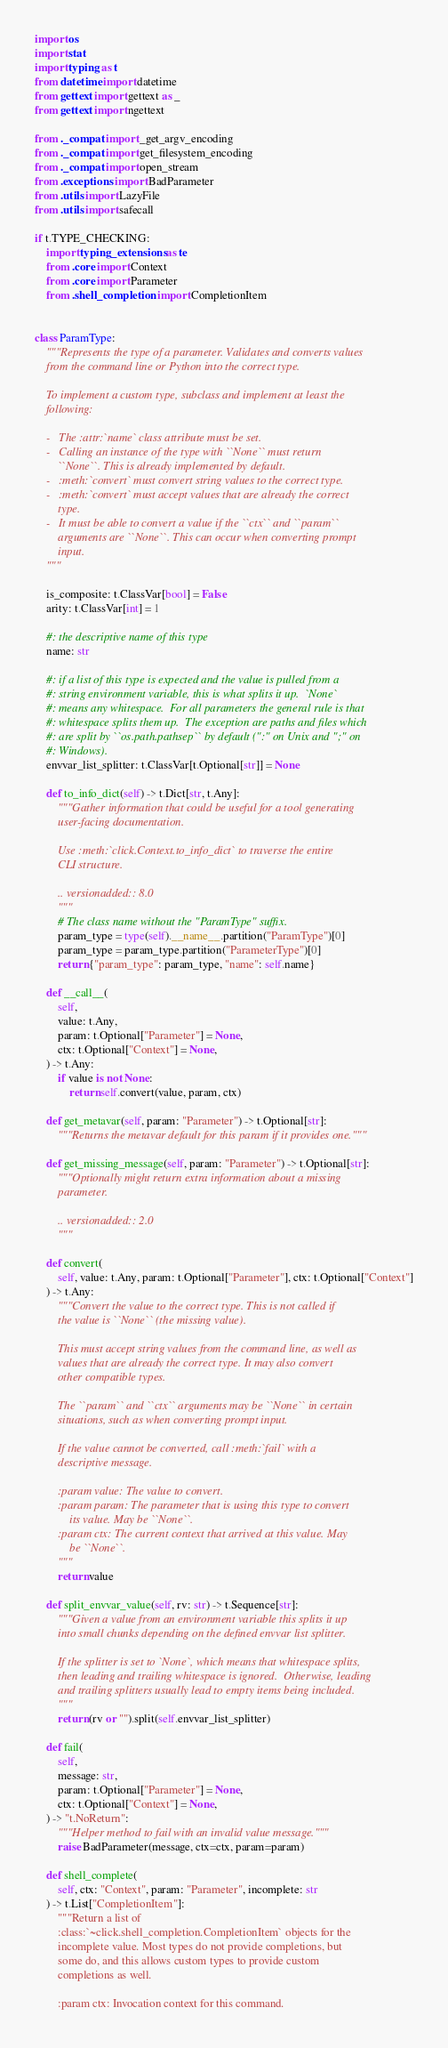Convert code to text. <code><loc_0><loc_0><loc_500><loc_500><_Python_>import os
import stat
import typing as t
from datetime import datetime
from gettext import gettext as _
from gettext import ngettext

from ._compat import _get_argv_encoding
from ._compat import get_filesystem_encoding
from ._compat import open_stream
from .exceptions import BadParameter
from .utils import LazyFile
from .utils import safecall

if t.TYPE_CHECKING:
    import typing_extensions as te
    from .core import Context
    from .core import Parameter
    from .shell_completion import CompletionItem


class ParamType:
    """Represents the type of a parameter. Validates and converts values
    from the command line or Python into the correct type.

    To implement a custom type, subclass and implement at least the
    following:

    -   The :attr:`name` class attribute must be set.
    -   Calling an instance of the type with ``None`` must return
        ``None``. This is already implemented by default.
    -   :meth:`convert` must convert string values to the correct type.
    -   :meth:`convert` must accept values that are already the correct
        type.
    -   It must be able to convert a value if the ``ctx`` and ``param``
        arguments are ``None``. This can occur when converting prompt
        input.
    """

    is_composite: t.ClassVar[bool] = False
    arity: t.ClassVar[int] = 1

    #: the descriptive name of this type
    name: str

    #: if a list of this type is expected and the value is pulled from a
    #: string environment variable, this is what splits it up.  `None`
    #: means any whitespace.  For all parameters the general rule is that
    #: whitespace splits them up.  The exception are paths and files which
    #: are split by ``os.path.pathsep`` by default (":" on Unix and ";" on
    #: Windows).
    envvar_list_splitter: t.ClassVar[t.Optional[str]] = None

    def to_info_dict(self) -> t.Dict[str, t.Any]:
        """Gather information that could be useful for a tool generating
        user-facing documentation.

        Use :meth:`click.Context.to_info_dict` to traverse the entire
        CLI structure.

        .. versionadded:: 8.0
        """
        # The class name without the "ParamType" suffix.
        param_type = type(self).__name__.partition("ParamType")[0]
        param_type = param_type.partition("ParameterType")[0]
        return {"param_type": param_type, "name": self.name}

    def __call__(
        self,
        value: t.Any,
        param: t.Optional["Parameter"] = None,
        ctx: t.Optional["Context"] = None,
    ) -> t.Any:
        if value is not None:
            return self.convert(value, param, ctx)

    def get_metavar(self, param: "Parameter") -> t.Optional[str]:
        """Returns the metavar default for this param if it provides one."""

    def get_missing_message(self, param: "Parameter") -> t.Optional[str]:
        """Optionally might return extra information about a missing
        parameter.

        .. versionadded:: 2.0
        """

    def convert(
        self, value: t.Any, param: t.Optional["Parameter"], ctx: t.Optional["Context"]
    ) -> t.Any:
        """Convert the value to the correct type. This is not called if
        the value is ``None`` (the missing value).

        This must accept string values from the command line, as well as
        values that are already the correct type. It may also convert
        other compatible types.

        The ``param`` and ``ctx`` arguments may be ``None`` in certain
        situations, such as when converting prompt input.

        If the value cannot be converted, call :meth:`fail` with a
        descriptive message.

        :param value: The value to convert.
        :param param: The parameter that is using this type to convert
            its value. May be ``None``.
        :param ctx: The current context that arrived at this value. May
            be ``None``.
        """
        return value

    def split_envvar_value(self, rv: str) -> t.Sequence[str]:
        """Given a value from an environment variable this splits it up
        into small chunks depending on the defined envvar list splitter.

        If the splitter is set to `None`, which means that whitespace splits,
        then leading and trailing whitespace is ignored.  Otherwise, leading
        and trailing splitters usually lead to empty items being included.
        """
        return (rv or "").split(self.envvar_list_splitter)

    def fail(
        self,
        message: str,
        param: t.Optional["Parameter"] = None,
        ctx: t.Optional["Context"] = None,
    ) -> "t.NoReturn":
        """Helper method to fail with an invalid value message."""
        raise BadParameter(message, ctx=ctx, param=param)

    def shell_complete(
        self, ctx: "Context", param: "Parameter", incomplete: str
    ) -> t.List["CompletionItem"]:
        """Return a list of
        :class:`~click.shell_completion.CompletionItem` objects for the
        incomplete value. Most types do not provide completions, but
        some do, and this allows custom types to provide custom
        completions as well.

        :param ctx: Invocation context for this command.</code> 